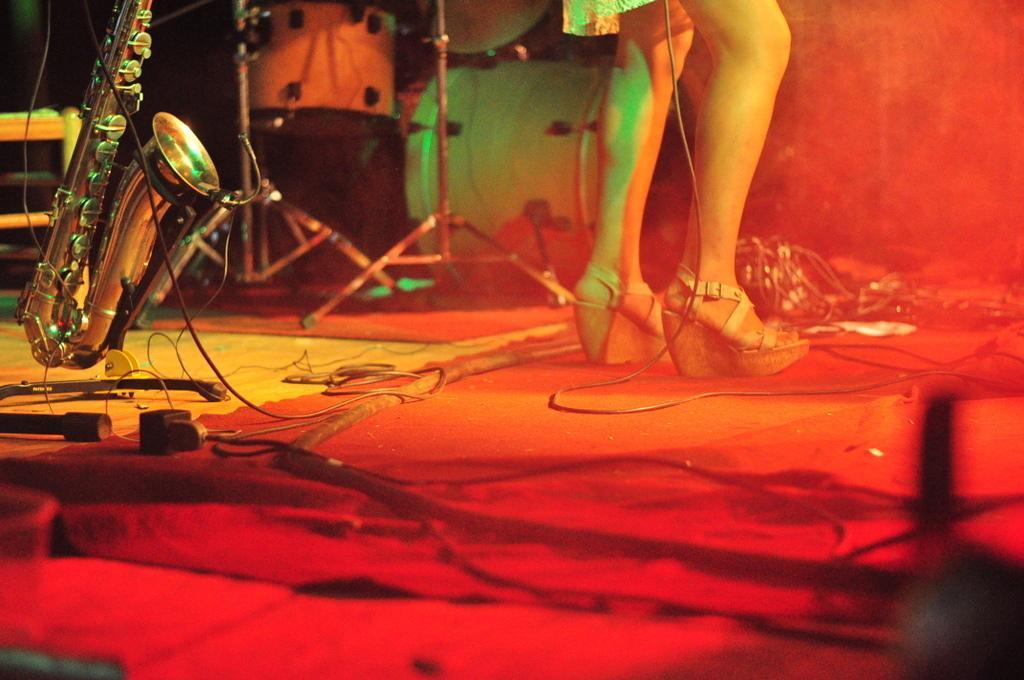How would you summarize this image in a sentence or two? There is a person standing. We can see musical instrument with stand and cables on the floor. Behind this person we can see musical instrument. 